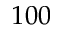Convert formula to latex. <formula><loc_0><loc_0><loc_500><loc_500>1 0 0</formula> 